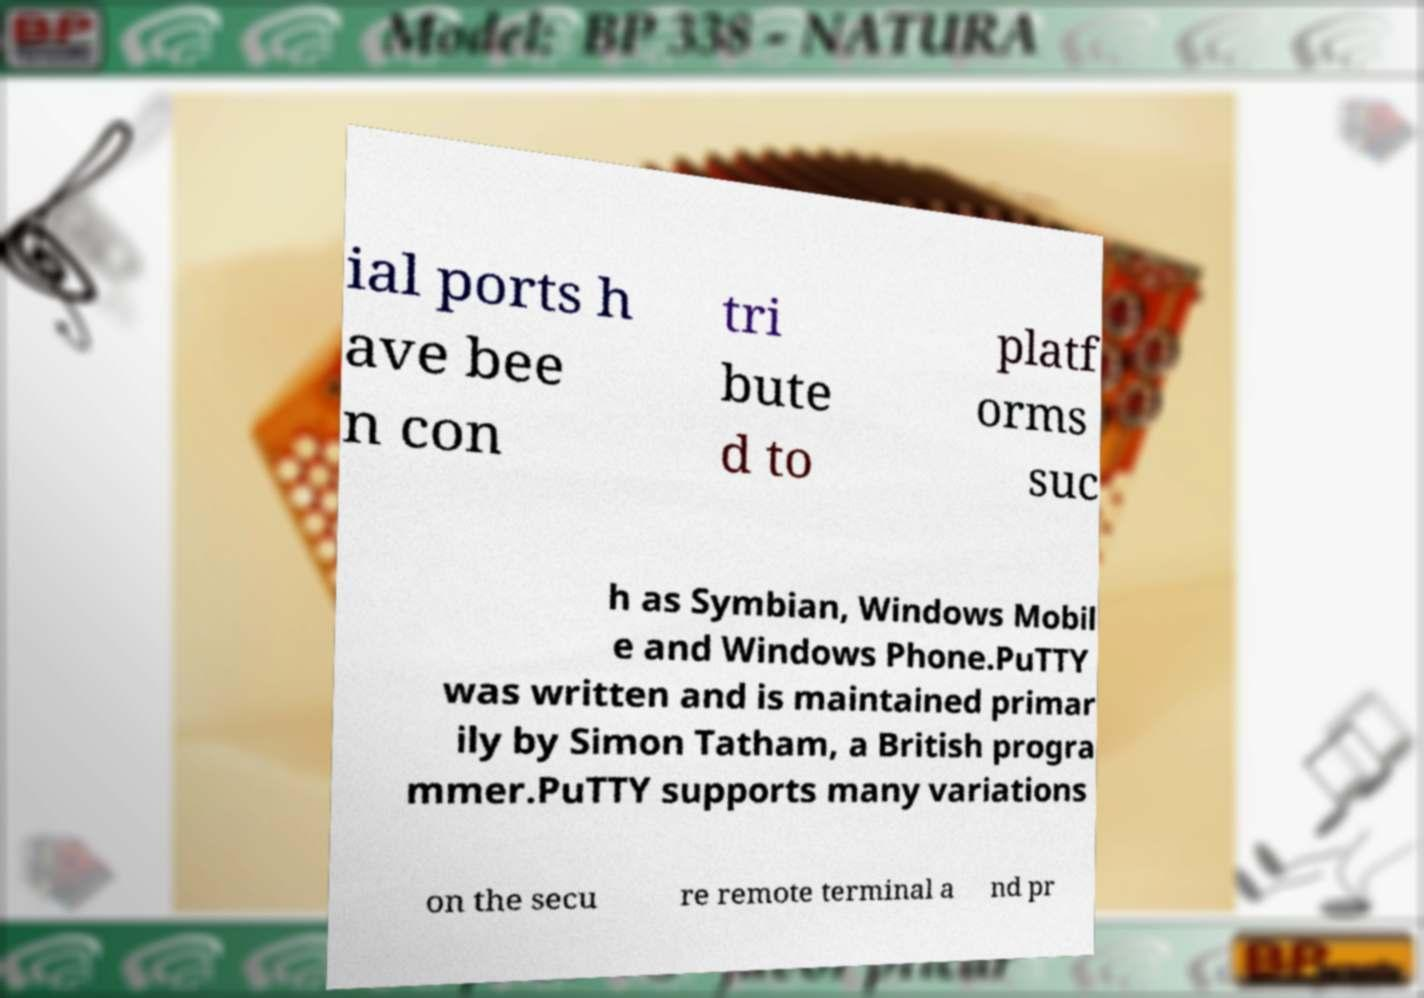Could you assist in decoding the text presented in this image and type it out clearly? ial ports h ave bee n con tri bute d to platf orms suc h as Symbian, Windows Mobil e and Windows Phone.PuTTY was written and is maintained primar ily by Simon Tatham, a British progra mmer.PuTTY supports many variations on the secu re remote terminal a nd pr 